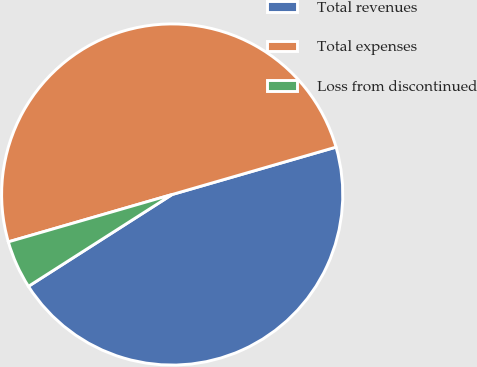Convert chart to OTSL. <chart><loc_0><loc_0><loc_500><loc_500><pie_chart><fcel>Total revenues<fcel>Total expenses<fcel>Loss from discontinued<nl><fcel>45.43%<fcel>50.0%<fcel>4.57%<nl></chart> 